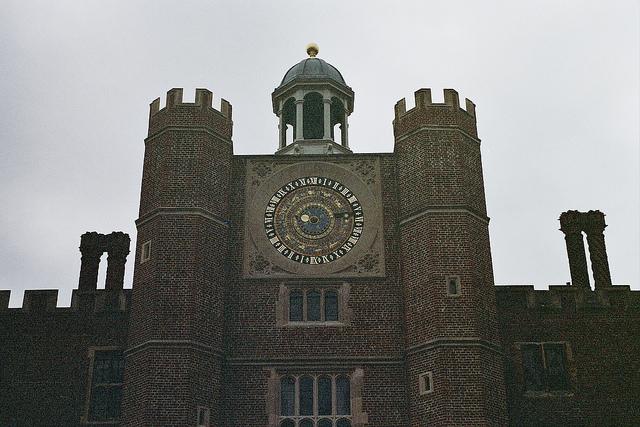Is this a castle?
Be succinct. Yes. Is there a clock on the building?
Keep it brief. Yes. Is it cloudy or sunny?
Concise answer only. Cloudy. 